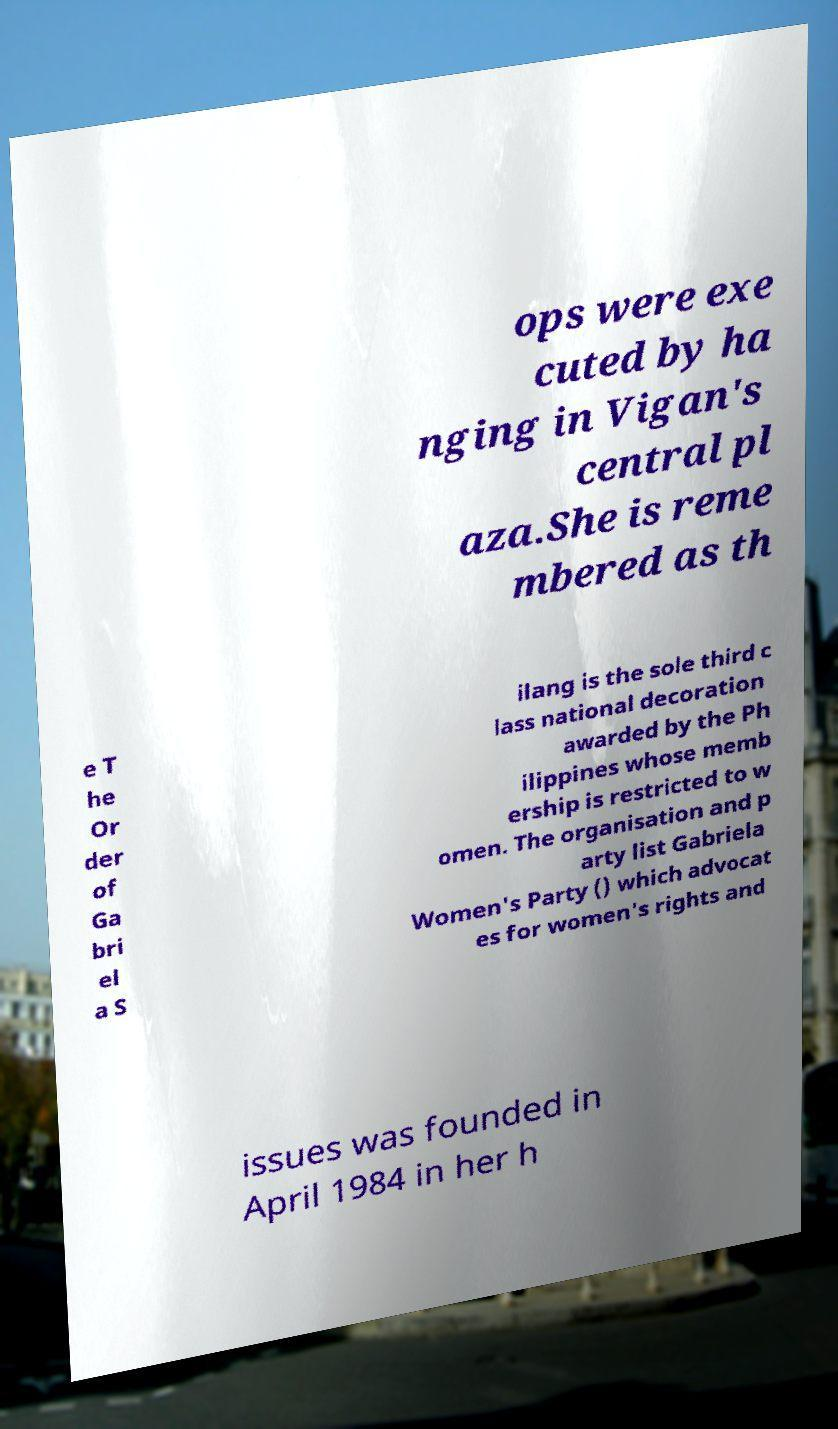Please read and relay the text visible in this image. What does it say? ops were exe cuted by ha nging in Vigan's central pl aza.She is reme mbered as th e T he Or der of Ga bri el a S ilang is the sole third c lass national decoration awarded by the Ph ilippines whose memb ership is restricted to w omen. The organisation and p arty list Gabriela Women's Party () which advocat es for women's rights and issues was founded in April 1984 in her h 